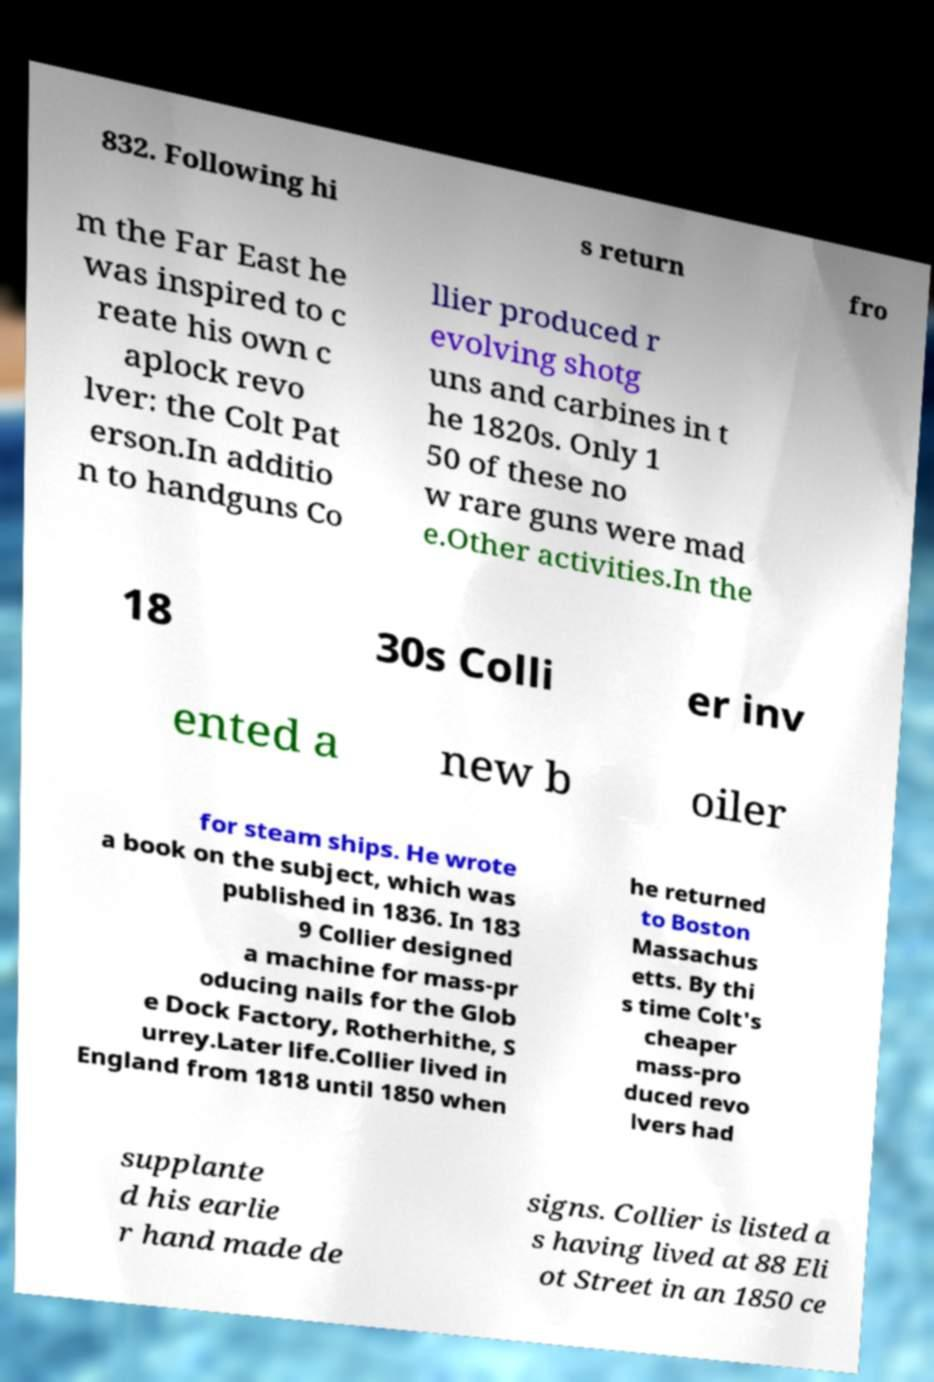There's text embedded in this image that I need extracted. Can you transcribe it verbatim? 832. Following hi s return fro m the Far East he was inspired to c reate his own c aplock revo lver: the Colt Pat erson.In additio n to handguns Co llier produced r evolving shotg uns and carbines in t he 1820s. Only 1 50 of these no w rare guns were mad e.Other activities.In the 18 30s Colli er inv ented a new b oiler for steam ships. He wrote a book on the subject, which was published in 1836. In 183 9 Collier designed a machine for mass-pr oducing nails for the Glob e Dock Factory, Rotherhithe, S urrey.Later life.Collier lived in England from 1818 until 1850 when he returned to Boston Massachus etts. By thi s time Colt's cheaper mass-pro duced revo lvers had supplante d his earlie r hand made de signs. Collier is listed a s having lived at 88 Eli ot Street in an 1850 ce 